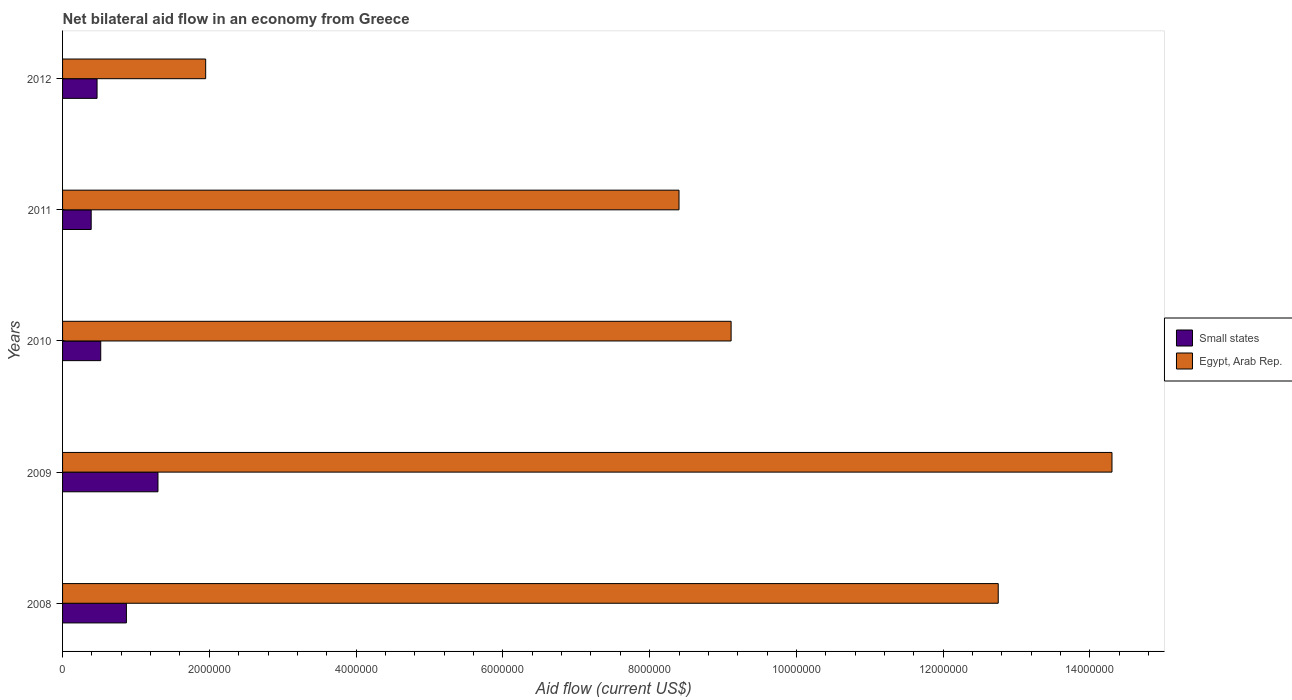How many different coloured bars are there?
Keep it short and to the point. 2. Are the number of bars on each tick of the Y-axis equal?
Offer a very short reply. Yes. How many bars are there on the 1st tick from the top?
Your answer should be compact. 2. What is the label of the 3rd group of bars from the top?
Offer a terse response. 2010. What is the net bilateral aid flow in Egypt, Arab Rep. in 2012?
Give a very brief answer. 1.95e+06. Across all years, what is the maximum net bilateral aid flow in Egypt, Arab Rep.?
Keep it short and to the point. 1.43e+07. Across all years, what is the minimum net bilateral aid flow in Egypt, Arab Rep.?
Offer a terse response. 1.95e+06. In which year was the net bilateral aid flow in Egypt, Arab Rep. minimum?
Keep it short and to the point. 2012. What is the total net bilateral aid flow in Small states in the graph?
Your answer should be compact. 3.55e+06. What is the difference between the net bilateral aid flow in Small states in 2009 and that in 2012?
Offer a very short reply. 8.30e+05. What is the difference between the net bilateral aid flow in Small states in 2008 and the net bilateral aid flow in Egypt, Arab Rep. in 2012?
Provide a short and direct response. -1.08e+06. What is the average net bilateral aid flow in Small states per year?
Provide a succinct answer. 7.10e+05. In the year 2011, what is the difference between the net bilateral aid flow in Small states and net bilateral aid flow in Egypt, Arab Rep.?
Give a very brief answer. -8.01e+06. What is the ratio of the net bilateral aid flow in Egypt, Arab Rep. in 2011 to that in 2012?
Your answer should be very brief. 4.31. Is the net bilateral aid flow in Egypt, Arab Rep. in 2008 less than that in 2012?
Keep it short and to the point. No. What is the difference between the highest and the second highest net bilateral aid flow in Egypt, Arab Rep.?
Provide a succinct answer. 1.55e+06. What is the difference between the highest and the lowest net bilateral aid flow in Small states?
Make the answer very short. 9.10e+05. What does the 2nd bar from the top in 2012 represents?
Your answer should be very brief. Small states. What does the 1st bar from the bottom in 2008 represents?
Ensure brevity in your answer.  Small states. How many bars are there?
Keep it short and to the point. 10. What is the difference between two consecutive major ticks on the X-axis?
Your response must be concise. 2.00e+06. Does the graph contain grids?
Your response must be concise. No. Where does the legend appear in the graph?
Provide a succinct answer. Center right. What is the title of the graph?
Ensure brevity in your answer.  Net bilateral aid flow in an economy from Greece. Does "Burundi" appear as one of the legend labels in the graph?
Provide a short and direct response. No. What is the Aid flow (current US$) of Small states in 2008?
Provide a succinct answer. 8.70e+05. What is the Aid flow (current US$) of Egypt, Arab Rep. in 2008?
Offer a terse response. 1.28e+07. What is the Aid flow (current US$) in Small states in 2009?
Provide a short and direct response. 1.30e+06. What is the Aid flow (current US$) of Egypt, Arab Rep. in 2009?
Keep it short and to the point. 1.43e+07. What is the Aid flow (current US$) of Small states in 2010?
Offer a very short reply. 5.20e+05. What is the Aid flow (current US$) of Egypt, Arab Rep. in 2010?
Your answer should be compact. 9.11e+06. What is the Aid flow (current US$) of Egypt, Arab Rep. in 2011?
Offer a very short reply. 8.40e+06. What is the Aid flow (current US$) of Egypt, Arab Rep. in 2012?
Provide a succinct answer. 1.95e+06. Across all years, what is the maximum Aid flow (current US$) in Small states?
Make the answer very short. 1.30e+06. Across all years, what is the maximum Aid flow (current US$) of Egypt, Arab Rep.?
Provide a succinct answer. 1.43e+07. Across all years, what is the minimum Aid flow (current US$) of Egypt, Arab Rep.?
Ensure brevity in your answer.  1.95e+06. What is the total Aid flow (current US$) in Small states in the graph?
Your answer should be compact. 3.55e+06. What is the total Aid flow (current US$) in Egypt, Arab Rep. in the graph?
Your answer should be very brief. 4.65e+07. What is the difference between the Aid flow (current US$) in Small states in 2008 and that in 2009?
Make the answer very short. -4.30e+05. What is the difference between the Aid flow (current US$) of Egypt, Arab Rep. in 2008 and that in 2009?
Make the answer very short. -1.55e+06. What is the difference between the Aid flow (current US$) of Small states in 2008 and that in 2010?
Offer a very short reply. 3.50e+05. What is the difference between the Aid flow (current US$) of Egypt, Arab Rep. in 2008 and that in 2010?
Provide a succinct answer. 3.64e+06. What is the difference between the Aid flow (current US$) of Egypt, Arab Rep. in 2008 and that in 2011?
Your response must be concise. 4.35e+06. What is the difference between the Aid flow (current US$) of Small states in 2008 and that in 2012?
Ensure brevity in your answer.  4.00e+05. What is the difference between the Aid flow (current US$) of Egypt, Arab Rep. in 2008 and that in 2012?
Provide a succinct answer. 1.08e+07. What is the difference between the Aid flow (current US$) of Small states in 2009 and that in 2010?
Offer a terse response. 7.80e+05. What is the difference between the Aid flow (current US$) of Egypt, Arab Rep. in 2009 and that in 2010?
Your answer should be compact. 5.19e+06. What is the difference between the Aid flow (current US$) of Small states in 2009 and that in 2011?
Your response must be concise. 9.10e+05. What is the difference between the Aid flow (current US$) in Egypt, Arab Rep. in 2009 and that in 2011?
Your response must be concise. 5.90e+06. What is the difference between the Aid flow (current US$) of Small states in 2009 and that in 2012?
Give a very brief answer. 8.30e+05. What is the difference between the Aid flow (current US$) in Egypt, Arab Rep. in 2009 and that in 2012?
Ensure brevity in your answer.  1.24e+07. What is the difference between the Aid flow (current US$) of Small states in 2010 and that in 2011?
Your answer should be compact. 1.30e+05. What is the difference between the Aid flow (current US$) of Egypt, Arab Rep. in 2010 and that in 2011?
Provide a succinct answer. 7.10e+05. What is the difference between the Aid flow (current US$) of Small states in 2010 and that in 2012?
Offer a terse response. 5.00e+04. What is the difference between the Aid flow (current US$) of Egypt, Arab Rep. in 2010 and that in 2012?
Make the answer very short. 7.16e+06. What is the difference between the Aid flow (current US$) of Egypt, Arab Rep. in 2011 and that in 2012?
Keep it short and to the point. 6.45e+06. What is the difference between the Aid flow (current US$) of Small states in 2008 and the Aid flow (current US$) of Egypt, Arab Rep. in 2009?
Ensure brevity in your answer.  -1.34e+07. What is the difference between the Aid flow (current US$) of Small states in 2008 and the Aid flow (current US$) of Egypt, Arab Rep. in 2010?
Your answer should be very brief. -8.24e+06. What is the difference between the Aid flow (current US$) of Small states in 2008 and the Aid flow (current US$) of Egypt, Arab Rep. in 2011?
Provide a short and direct response. -7.53e+06. What is the difference between the Aid flow (current US$) of Small states in 2008 and the Aid flow (current US$) of Egypt, Arab Rep. in 2012?
Your answer should be compact. -1.08e+06. What is the difference between the Aid flow (current US$) in Small states in 2009 and the Aid flow (current US$) in Egypt, Arab Rep. in 2010?
Provide a short and direct response. -7.81e+06. What is the difference between the Aid flow (current US$) in Small states in 2009 and the Aid flow (current US$) in Egypt, Arab Rep. in 2011?
Provide a short and direct response. -7.10e+06. What is the difference between the Aid flow (current US$) of Small states in 2009 and the Aid flow (current US$) of Egypt, Arab Rep. in 2012?
Offer a terse response. -6.50e+05. What is the difference between the Aid flow (current US$) in Small states in 2010 and the Aid flow (current US$) in Egypt, Arab Rep. in 2011?
Keep it short and to the point. -7.88e+06. What is the difference between the Aid flow (current US$) of Small states in 2010 and the Aid flow (current US$) of Egypt, Arab Rep. in 2012?
Keep it short and to the point. -1.43e+06. What is the difference between the Aid flow (current US$) in Small states in 2011 and the Aid flow (current US$) in Egypt, Arab Rep. in 2012?
Your answer should be compact. -1.56e+06. What is the average Aid flow (current US$) of Small states per year?
Provide a short and direct response. 7.10e+05. What is the average Aid flow (current US$) in Egypt, Arab Rep. per year?
Give a very brief answer. 9.30e+06. In the year 2008, what is the difference between the Aid flow (current US$) of Small states and Aid flow (current US$) of Egypt, Arab Rep.?
Your answer should be very brief. -1.19e+07. In the year 2009, what is the difference between the Aid flow (current US$) of Small states and Aid flow (current US$) of Egypt, Arab Rep.?
Keep it short and to the point. -1.30e+07. In the year 2010, what is the difference between the Aid flow (current US$) in Small states and Aid flow (current US$) in Egypt, Arab Rep.?
Your answer should be compact. -8.59e+06. In the year 2011, what is the difference between the Aid flow (current US$) of Small states and Aid flow (current US$) of Egypt, Arab Rep.?
Offer a very short reply. -8.01e+06. In the year 2012, what is the difference between the Aid flow (current US$) in Small states and Aid flow (current US$) in Egypt, Arab Rep.?
Provide a short and direct response. -1.48e+06. What is the ratio of the Aid flow (current US$) in Small states in 2008 to that in 2009?
Provide a short and direct response. 0.67. What is the ratio of the Aid flow (current US$) of Egypt, Arab Rep. in 2008 to that in 2009?
Ensure brevity in your answer.  0.89. What is the ratio of the Aid flow (current US$) in Small states in 2008 to that in 2010?
Offer a very short reply. 1.67. What is the ratio of the Aid flow (current US$) in Egypt, Arab Rep. in 2008 to that in 2010?
Your answer should be compact. 1.4. What is the ratio of the Aid flow (current US$) in Small states in 2008 to that in 2011?
Offer a terse response. 2.23. What is the ratio of the Aid flow (current US$) of Egypt, Arab Rep. in 2008 to that in 2011?
Offer a terse response. 1.52. What is the ratio of the Aid flow (current US$) in Small states in 2008 to that in 2012?
Ensure brevity in your answer.  1.85. What is the ratio of the Aid flow (current US$) in Egypt, Arab Rep. in 2008 to that in 2012?
Offer a very short reply. 6.54. What is the ratio of the Aid flow (current US$) in Egypt, Arab Rep. in 2009 to that in 2010?
Ensure brevity in your answer.  1.57. What is the ratio of the Aid flow (current US$) of Egypt, Arab Rep. in 2009 to that in 2011?
Provide a short and direct response. 1.7. What is the ratio of the Aid flow (current US$) in Small states in 2009 to that in 2012?
Keep it short and to the point. 2.77. What is the ratio of the Aid flow (current US$) in Egypt, Arab Rep. in 2009 to that in 2012?
Your response must be concise. 7.33. What is the ratio of the Aid flow (current US$) in Small states in 2010 to that in 2011?
Offer a very short reply. 1.33. What is the ratio of the Aid flow (current US$) of Egypt, Arab Rep. in 2010 to that in 2011?
Provide a short and direct response. 1.08. What is the ratio of the Aid flow (current US$) of Small states in 2010 to that in 2012?
Give a very brief answer. 1.11. What is the ratio of the Aid flow (current US$) of Egypt, Arab Rep. in 2010 to that in 2012?
Offer a terse response. 4.67. What is the ratio of the Aid flow (current US$) of Small states in 2011 to that in 2012?
Ensure brevity in your answer.  0.83. What is the ratio of the Aid flow (current US$) of Egypt, Arab Rep. in 2011 to that in 2012?
Your answer should be very brief. 4.31. What is the difference between the highest and the second highest Aid flow (current US$) in Egypt, Arab Rep.?
Your response must be concise. 1.55e+06. What is the difference between the highest and the lowest Aid flow (current US$) of Small states?
Your answer should be very brief. 9.10e+05. What is the difference between the highest and the lowest Aid flow (current US$) of Egypt, Arab Rep.?
Offer a very short reply. 1.24e+07. 